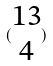<formula> <loc_0><loc_0><loc_500><loc_500>( \begin{matrix} 1 3 \\ 4 \end{matrix} )</formula> 